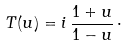<formula> <loc_0><loc_0><loc_500><loc_500>T ( u ) = i \, \frac { 1 + u } { 1 - u } \, \cdot</formula> 